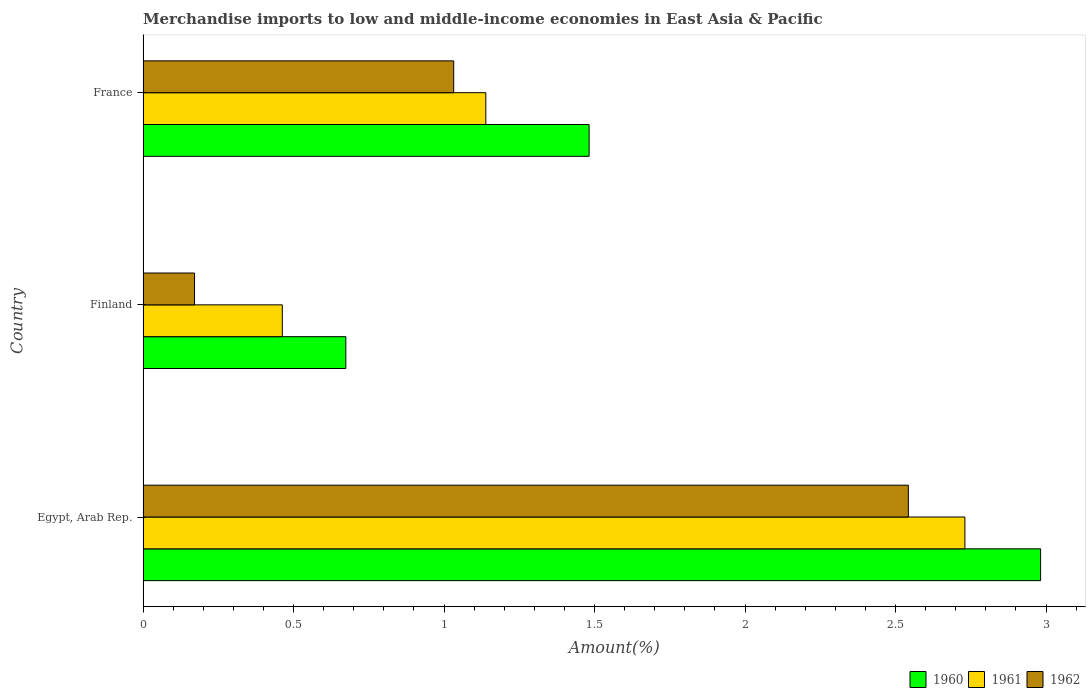How many different coloured bars are there?
Offer a terse response. 3. How many groups of bars are there?
Provide a succinct answer. 3. Are the number of bars per tick equal to the number of legend labels?
Offer a terse response. Yes. What is the label of the 2nd group of bars from the top?
Provide a succinct answer. Finland. What is the percentage of amount earned from merchandise imports in 1960 in Finland?
Your answer should be very brief. 0.67. Across all countries, what is the maximum percentage of amount earned from merchandise imports in 1962?
Provide a short and direct response. 2.54. Across all countries, what is the minimum percentage of amount earned from merchandise imports in 1961?
Offer a terse response. 0.46. In which country was the percentage of amount earned from merchandise imports in 1962 maximum?
Your answer should be very brief. Egypt, Arab Rep. In which country was the percentage of amount earned from merchandise imports in 1961 minimum?
Your response must be concise. Finland. What is the total percentage of amount earned from merchandise imports in 1961 in the graph?
Provide a succinct answer. 4.33. What is the difference between the percentage of amount earned from merchandise imports in 1960 in Finland and that in France?
Keep it short and to the point. -0.81. What is the difference between the percentage of amount earned from merchandise imports in 1960 in Finland and the percentage of amount earned from merchandise imports in 1962 in France?
Make the answer very short. -0.36. What is the average percentage of amount earned from merchandise imports in 1962 per country?
Keep it short and to the point. 1.25. What is the difference between the percentage of amount earned from merchandise imports in 1960 and percentage of amount earned from merchandise imports in 1961 in Finland?
Give a very brief answer. 0.21. In how many countries, is the percentage of amount earned from merchandise imports in 1961 greater than 1.7 %?
Make the answer very short. 1. What is the ratio of the percentage of amount earned from merchandise imports in 1960 in Egypt, Arab Rep. to that in France?
Ensure brevity in your answer.  2.01. What is the difference between the highest and the second highest percentage of amount earned from merchandise imports in 1962?
Keep it short and to the point. 1.51. What is the difference between the highest and the lowest percentage of amount earned from merchandise imports in 1960?
Make the answer very short. 2.31. In how many countries, is the percentage of amount earned from merchandise imports in 1960 greater than the average percentage of amount earned from merchandise imports in 1960 taken over all countries?
Provide a succinct answer. 1. What does the 3rd bar from the top in Finland represents?
Offer a terse response. 1960. How many bars are there?
Provide a short and direct response. 9. Are all the bars in the graph horizontal?
Your answer should be very brief. Yes. How many countries are there in the graph?
Provide a succinct answer. 3. What is the difference between two consecutive major ticks on the X-axis?
Your answer should be very brief. 0.5. Does the graph contain any zero values?
Offer a very short reply. No. What is the title of the graph?
Ensure brevity in your answer.  Merchandise imports to low and middle-income economies in East Asia & Pacific. What is the label or title of the X-axis?
Your answer should be compact. Amount(%). What is the label or title of the Y-axis?
Offer a terse response. Country. What is the Amount(%) of 1960 in Egypt, Arab Rep.?
Ensure brevity in your answer.  2.98. What is the Amount(%) in 1961 in Egypt, Arab Rep.?
Offer a very short reply. 2.73. What is the Amount(%) in 1962 in Egypt, Arab Rep.?
Give a very brief answer. 2.54. What is the Amount(%) of 1960 in Finland?
Provide a succinct answer. 0.67. What is the Amount(%) of 1961 in Finland?
Provide a succinct answer. 0.46. What is the Amount(%) in 1962 in Finland?
Offer a terse response. 0.17. What is the Amount(%) in 1960 in France?
Your response must be concise. 1.48. What is the Amount(%) in 1961 in France?
Give a very brief answer. 1.14. What is the Amount(%) of 1962 in France?
Make the answer very short. 1.03. Across all countries, what is the maximum Amount(%) in 1960?
Ensure brevity in your answer.  2.98. Across all countries, what is the maximum Amount(%) of 1961?
Your answer should be compact. 2.73. Across all countries, what is the maximum Amount(%) of 1962?
Offer a terse response. 2.54. Across all countries, what is the minimum Amount(%) of 1960?
Your response must be concise. 0.67. Across all countries, what is the minimum Amount(%) in 1961?
Your answer should be very brief. 0.46. Across all countries, what is the minimum Amount(%) in 1962?
Provide a short and direct response. 0.17. What is the total Amount(%) of 1960 in the graph?
Provide a succinct answer. 5.14. What is the total Amount(%) in 1961 in the graph?
Provide a short and direct response. 4.33. What is the total Amount(%) of 1962 in the graph?
Offer a terse response. 3.75. What is the difference between the Amount(%) of 1960 in Egypt, Arab Rep. and that in Finland?
Your answer should be compact. 2.31. What is the difference between the Amount(%) in 1961 in Egypt, Arab Rep. and that in Finland?
Provide a succinct answer. 2.27. What is the difference between the Amount(%) of 1962 in Egypt, Arab Rep. and that in Finland?
Provide a short and direct response. 2.37. What is the difference between the Amount(%) in 1960 in Egypt, Arab Rep. and that in France?
Your answer should be compact. 1.5. What is the difference between the Amount(%) in 1961 in Egypt, Arab Rep. and that in France?
Give a very brief answer. 1.59. What is the difference between the Amount(%) of 1962 in Egypt, Arab Rep. and that in France?
Ensure brevity in your answer.  1.51. What is the difference between the Amount(%) in 1960 in Finland and that in France?
Offer a very short reply. -0.81. What is the difference between the Amount(%) in 1961 in Finland and that in France?
Make the answer very short. -0.68. What is the difference between the Amount(%) of 1962 in Finland and that in France?
Give a very brief answer. -0.86. What is the difference between the Amount(%) in 1960 in Egypt, Arab Rep. and the Amount(%) in 1961 in Finland?
Provide a short and direct response. 2.52. What is the difference between the Amount(%) of 1960 in Egypt, Arab Rep. and the Amount(%) of 1962 in Finland?
Keep it short and to the point. 2.81. What is the difference between the Amount(%) of 1961 in Egypt, Arab Rep. and the Amount(%) of 1962 in Finland?
Provide a succinct answer. 2.56. What is the difference between the Amount(%) in 1960 in Egypt, Arab Rep. and the Amount(%) in 1961 in France?
Offer a terse response. 1.84. What is the difference between the Amount(%) of 1960 in Egypt, Arab Rep. and the Amount(%) of 1962 in France?
Provide a short and direct response. 1.95. What is the difference between the Amount(%) of 1961 in Egypt, Arab Rep. and the Amount(%) of 1962 in France?
Provide a short and direct response. 1.7. What is the difference between the Amount(%) of 1960 in Finland and the Amount(%) of 1961 in France?
Make the answer very short. -0.47. What is the difference between the Amount(%) of 1960 in Finland and the Amount(%) of 1962 in France?
Offer a terse response. -0.36. What is the difference between the Amount(%) in 1961 in Finland and the Amount(%) in 1962 in France?
Your response must be concise. -0.57. What is the average Amount(%) of 1960 per country?
Ensure brevity in your answer.  1.71. What is the average Amount(%) of 1961 per country?
Provide a succinct answer. 1.44. What is the average Amount(%) of 1962 per country?
Give a very brief answer. 1.25. What is the difference between the Amount(%) in 1960 and Amount(%) in 1961 in Egypt, Arab Rep.?
Offer a very short reply. 0.25. What is the difference between the Amount(%) of 1960 and Amount(%) of 1962 in Egypt, Arab Rep.?
Your answer should be compact. 0.44. What is the difference between the Amount(%) in 1961 and Amount(%) in 1962 in Egypt, Arab Rep.?
Provide a short and direct response. 0.19. What is the difference between the Amount(%) in 1960 and Amount(%) in 1961 in Finland?
Your response must be concise. 0.21. What is the difference between the Amount(%) of 1960 and Amount(%) of 1962 in Finland?
Give a very brief answer. 0.5. What is the difference between the Amount(%) of 1961 and Amount(%) of 1962 in Finland?
Keep it short and to the point. 0.29. What is the difference between the Amount(%) in 1960 and Amount(%) in 1961 in France?
Offer a very short reply. 0.34. What is the difference between the Amount(%) in 1960 and Amount(%) in 1962 in France?
Your response must be concise. 0.45. What is the difference between the Amount(%) of 1961 and Amount(%) of 1962 in France?
Your answer should be very brief. 0.11. What is the ratio of the Amount(%) of 1960 in Egypt, Arab Rep. to that in Finland?
Give a very brief answer. 4.43. What is the ratio of the Amount(%) in 1961 in Egypt, Arab Rep. to that in Finland?
Provide a succinct answer. 5.9. What is the ratio of the Amount(%) in 1962 in Egypt, Arab Rep. to that in Finland?
Your answer should be compact. 14.87. What is the ratio of the Amount(%) in 1960 in Egypt, Arab Rep. to that in France?
Provide a short and direct response. 2.01. What is the ratio of the Amount(%) in 1961 in Egypt, Arab Rep. to that in France?
Make the answer very short. 2.4. What is the ratio of the Amount(%) of 1962 in Egypt, Arab Rep. to that in France?
Ensure brevity in your answer.  2.46. What is the ratio of the Amount(%) of 1960 in Finland to that in France?
Keep it short and to the point. 0.45. What is the ratio of the Amount(%) in 1961 in Finland to that in France?
Ensure brevity in your answer.  0.41. What is the ratio of the Amount(%) of 1962 in Finland to that in France?
Your response must be concise. 0.17. What is the difference between the highest and the second highest Amount(%) in 1960?
Give a very brief answer. 1.5. What is the difference between the highest and the second highest Amount(%) in 1961?
Offer a very short reply. 1.59. What is the difference between the highest and the second highest Amount(%) in 1962?
Ensure brevity in your answer.  1.51. What is the difference between the highest and the lowest Amount(%) in 1960?
Give a very brief answer. 2.31. What is the difference between the highest and the lowest Amount(%) of 1961?
Give a very brief answer. 2.27. What is the difference between the highest and the lowest Amount(%) of 1962?
Offer a terse response. 2.37. 